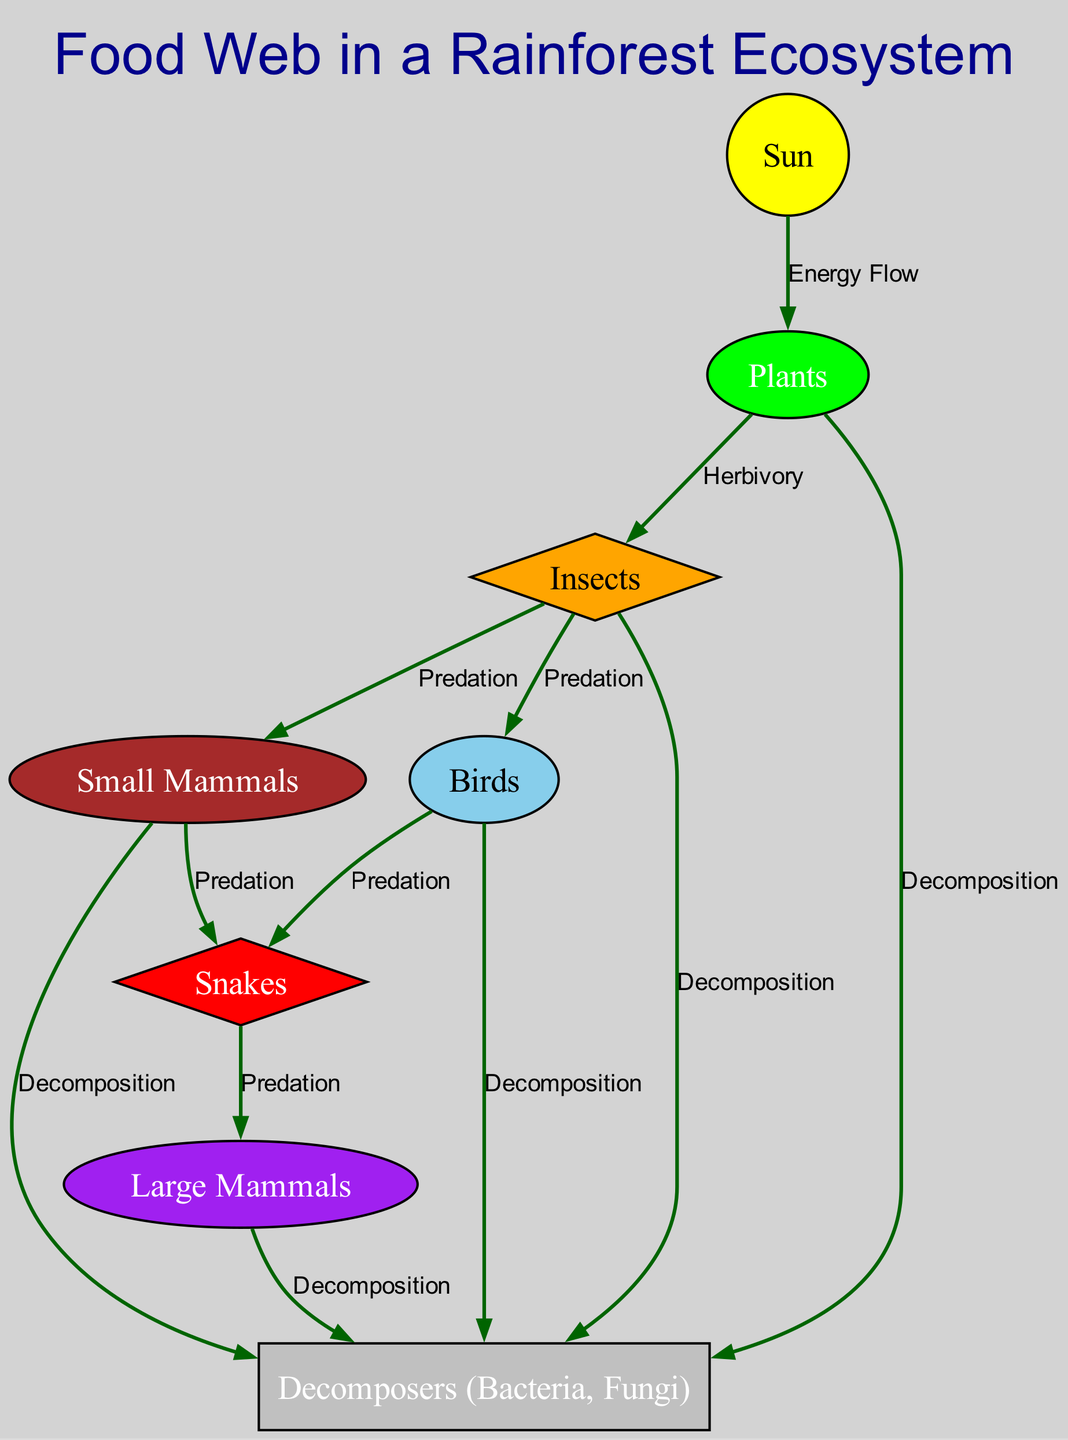What is the title of the diagram? The title is explicitly mentioned in the title attribute of the diagram data structure, which is "Food Web in a Rainforest Ecosystem."
Answer: Food Web in a Rainforest Ecosystem How many nodes are in the diagram? By counting the length of the 'nodes' list in the provided data, there are a total of 8 nodes depicted in the diagram.
Answer: 8 Which species are herbivores in the food web? By examining the relationships, the species that feed on plants (the primary producers) are labeled as herbivores. In this diagram, "Insects" and "Small Mammals" consume "Plants."
Answer: Insects, Small Mammals What is the relationship between "Birds" and "Snakes"? The relationship is found by checking the edges connecting these species in the diagram. "Birds" are prey to "Snakes," indicated by a direct edge labeled "Predation."
Answer: Predation Which species are decomposers in the ecosystem? The decomposers can be identified by looking for the node that specifically represents them, which in this case is labeled "Decomposers (Bacteria, Fungi)."
Answer: Decomposers (Bacteria, Fungi) How many predatory relationships involve "Small Mammals"? To answer this, we can examine the edges related to "Small Mammals." They are connected to "Snakes" and also to "Decomposers" through decomposition, leading to a total of 2 predatory relationships.
Answer: 2 What is the flow of energy starting from the "Sun"? The flow of energy begins at the "Sun," which is consumed by "Plants." From "Plants," energy moves to both "Insects" and "Small Mammals," showing a chain where energy is transferred through herbivory and then to predators.
Answer: Plants -> Insects, Small Mammals Which species are at the top of the food web? To determine this, we need to analyze which species do not have any arrows pointing to them indicating predation; "Large Mammals" appear at the top as they consume "Snakes," which consume other species, but are not predated upon in this diagram.
Answer: Large Mammals 